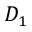<formula> <loc_0><loc_0><loc_500><loc_500>D _ { 1 }</formula> 